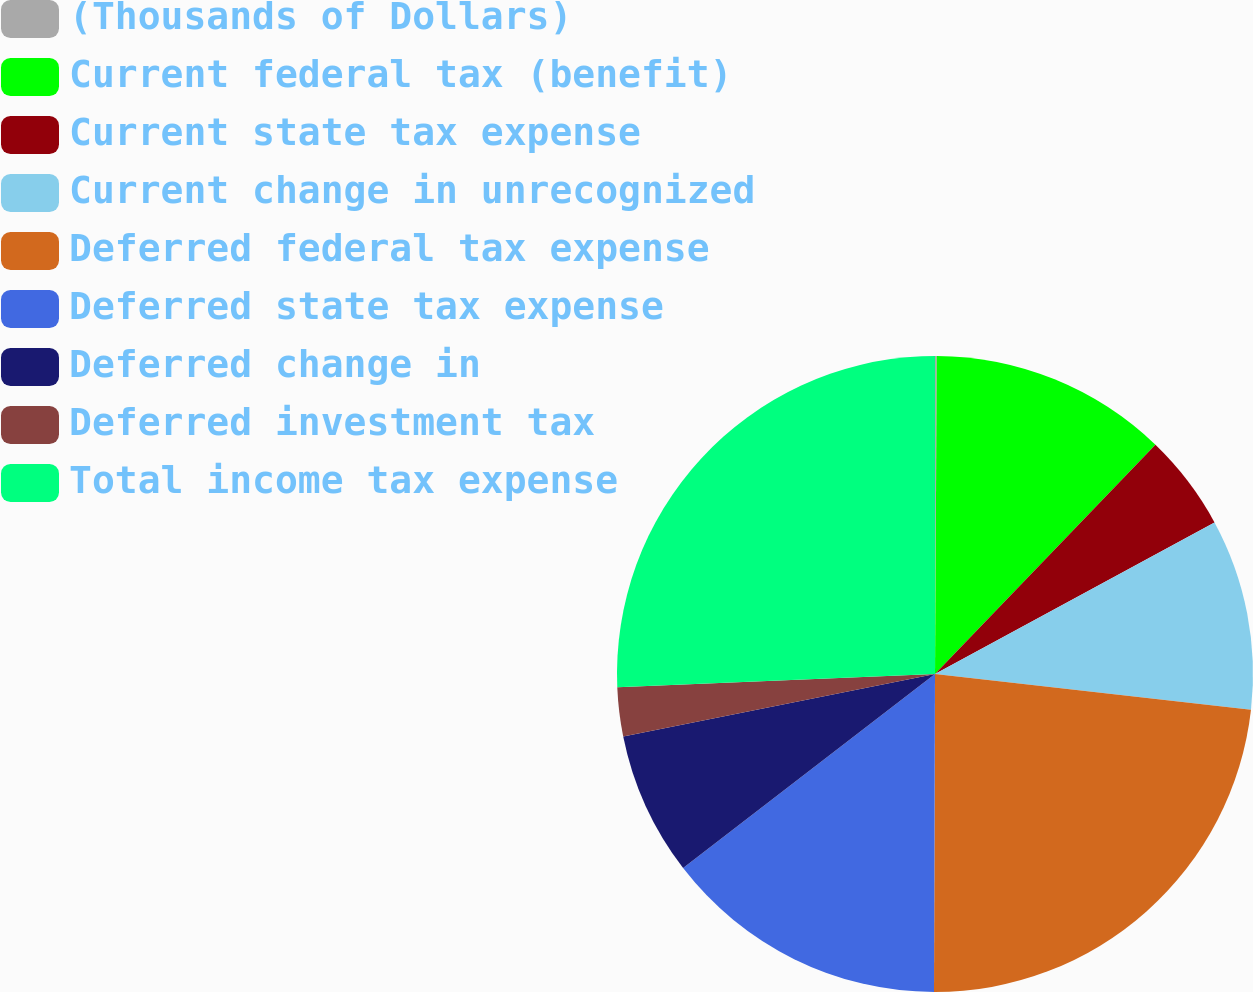<chart> <loc_0><loc_0><loc_500><loc_500><pie_chart><fcel>(Thousands of Dollars)<fcel>Current federal tax (benefit)<fcel>Current state tax expense<fcel>Current change in unrecognized<fcel>Deferred federal tax expense<fcel>Deferred state tax expense<fcel>Deferred change in<fcel>Deferred investment tax<fcel>Total income tax expense<nl><fcel>0.09%<fcel>12.1%<fcel>4.9%<fcel>9.7%<fcel>23.26%<fcel>14.5%<fcel>7.3%<fcel>2.49%<fcel>25.66%<nl></chart> 